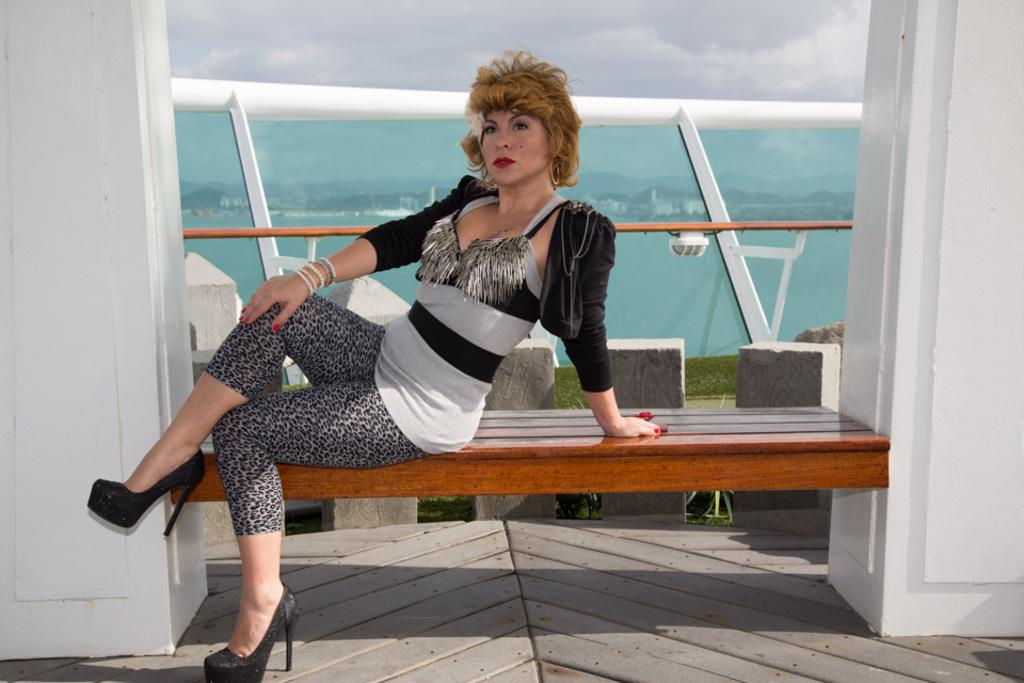What is the woman in the image doing? There is a woman sitting on a bench in the image. What is located behind the woman? There is a white pole behind the woman. What is the condition of the sky in the image? The sky is cloudy in the image. What type of celery is the woman holding in her hand in the image? There is no celery present in the image; the woman is sitting on a bench with a white pole behind her. 